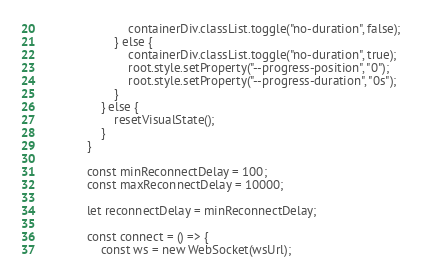<code> <loc_0><loc_0><loc_500><loc_500><_HTML_>                        containerDiv.classList.toggle("no-duration", false);
                    } else {
                        containerDiv.classList.toggle("no-duration", true);
                        root.style.setProperty("--progress-position", "0");
                        root.style.setProperty("--progress-duration", "0s");
                    }
                } else {
                    resetVisualState();
                }
            }

            const minReconnectDelay = 100;
            const maxReconnectDelay = 10000;

            let reconnectDelay = minReconnectDelay;

            const connect = () => {
                const ws = new WebSocket(wsUrl);
</code> 